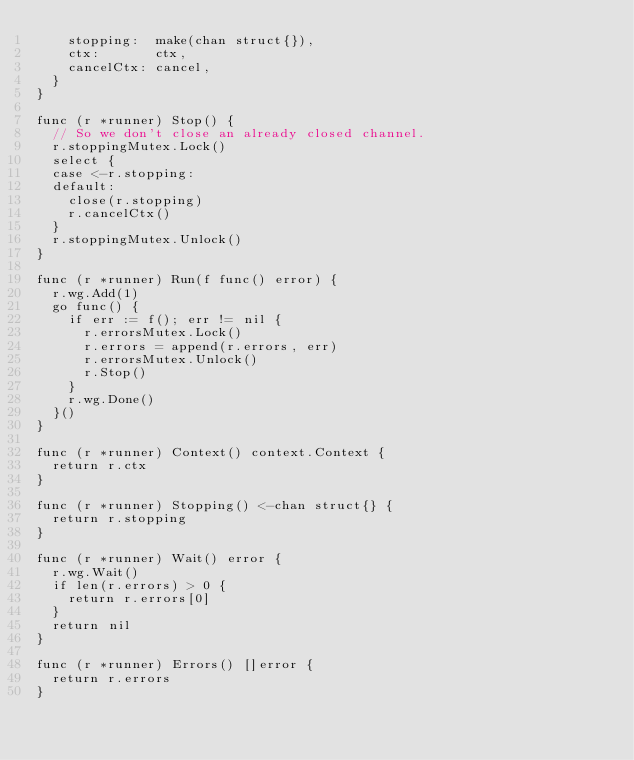<code> <loc_0><loc_0><loc_500><loc_500><_Go_>		stopping:  make(chan struct{}),
		ctx:       ctx,
		cancelCtx: cancel,
	}
}

func (r *runner) Stop() {
	// So we don't close an already closed channel.
	r.stoppingMutex.Lock()
	select {
	case <-r.stopping:
	default:
		close(r.stopping)
		r.cancelCtx()
	}
	r.stoppingMutex.Unlock()
}

func (r *runner) Run(f func() error) {
	r.wg.Add(1)
	go func() {
		if err := f(); err != nil {
			r.errorsMutex.Lock()
			r.errors = append(r.errors, err)
			r.errorsMutex.Unlock()
			r.Stop()
		}
		r.wg.Done()
	}()
}

func (r *runner) Context() context.Context {
	return r.ctx
}

func (r *runner) Stopping() <-chan struct{} {
	return r.stopping
}

func (r *runner) Wait() error {
	r.wg.Wait()
	if len(r.errors) > 0 {
		return r.errors[0]
	}
	return nil
}

func (r *runner) Errors() []error {
	return r.errors
}
</code> 